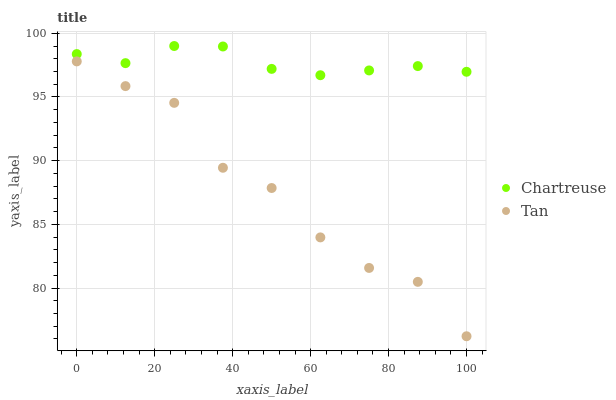Does Tan have the minimum area under the curve?
Answer yes or no. Yes. Does Chartreuse have the maximum area under the curve?
Answer yes or no. Yes. Does Tan have the maximum area under the curve?
Answer yes or no. No. Is Chartreuse the smoothest?
Answer yes or no. Yes. Is Tan the roughest?
Answer yes or no. Yes. Is Tan the smoothest?
Answer yes or no. No. Does Tan have the lowest value?
Answer yes or no. Yes. Does Chartreuse have the highest value?
Answer yes or no. Yes. Does Tan have the highest value?
Answer yes or no. No. Is Tan less than Chartreuse?
Answer yes or no. Yes. Is Chartreuse greater than Tan?
Answer yes or no. Yes. Does Tan intersect Chartreuse?
Answer yes or no. No. 